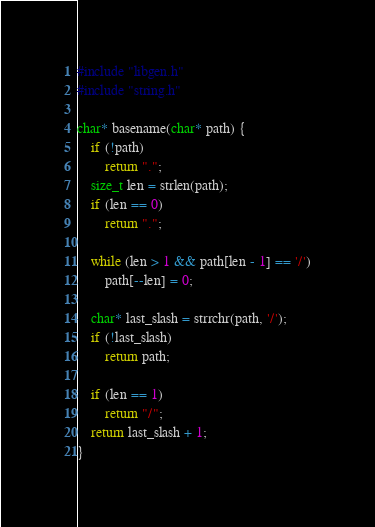<code> <loc_0><loc_0><loc_500><loc_500><_C_>#include "libgen.h"
#include "string.h"

char* basename(char* path) {
    if (!path)
        return ".";
    size_t len = strlen(path);
    if (len == 0)
        return ".";

    while (len > 1 && path[len - 1] == '/')
        path[--len] = 0;

    char* last_slash = strrchr(path, '/');
    if (!last_slash)
        return path;

    if (len == 1)
        return "/";
    return last_slash + 1;
}
</code> 